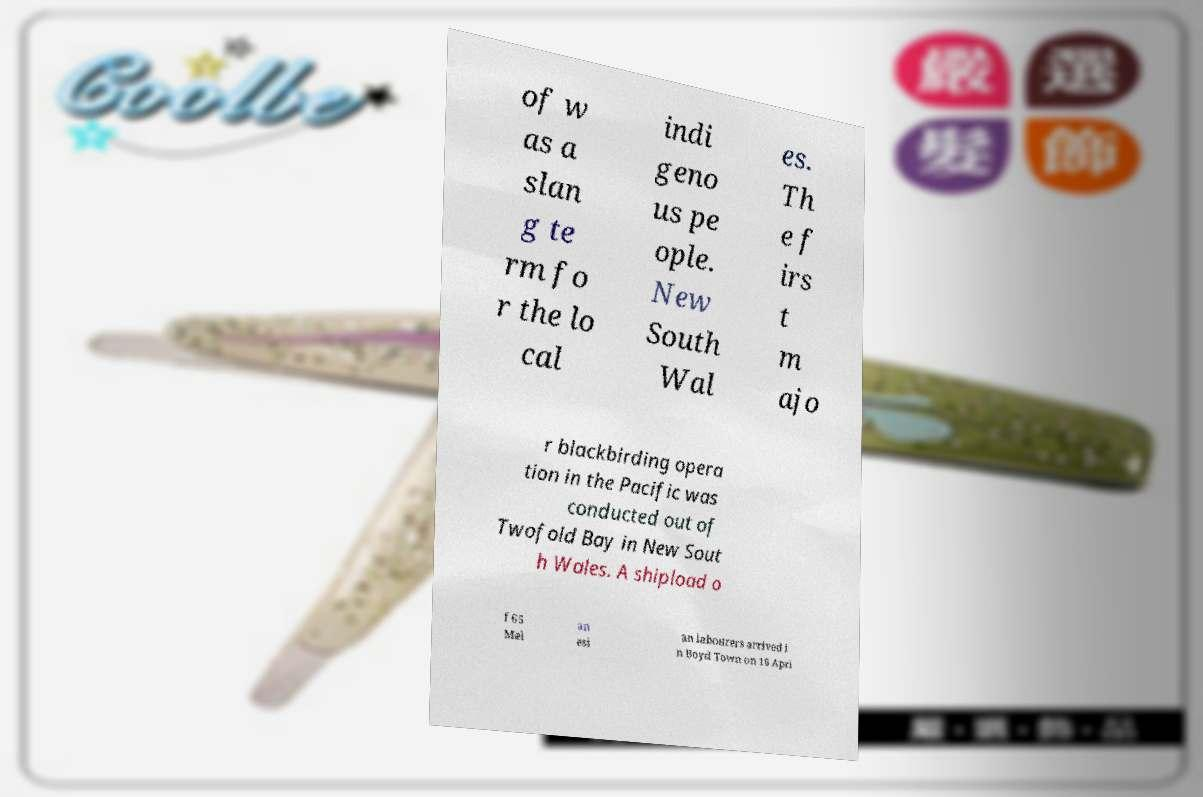What messages or text are displayed in this image? I need them in a readable, typed format. of w as a slan g te rm fo r the lo cal indi geno us pe ople. New South Wal es. Th e f irs t m ajo r blackbirding opera tion in the Pacific was conducted out of Twofold Bay in New Sout h Wales. A shipload o f 65 Mel an esi an labourers arrived i n Boyd Town on 16 Apri 